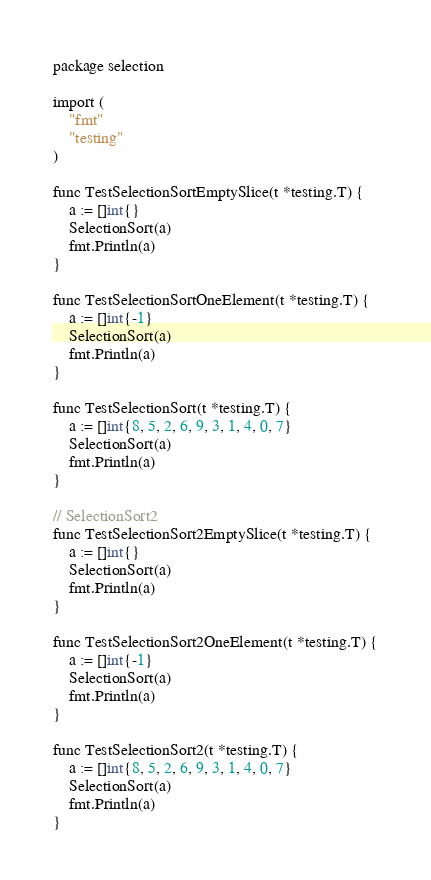<code> <loc_0><loc_0><loc_500><loc_500><_Go_>package selection

import (
	"fmt"
	"testing"
)

func TestSelectionSortEmptySlice(t *testing.T) {
	a := []int{}
	SelectionSort(a)
	fmt.Println(a)
}

func TestSelectionSortOneElement(t *testing.T) {
	a := []int{-1}
	SelectionSort(a)
	fmt.Println(a)
}

func TestSelectionSort(t *testing.T) {
	a := []int{8, 5, 2, 6, 9, 3, 1, 4, 0, 7}
	SelectionSort(a)
	fmt.Println(a)
}

// SelectionSort2
func TestSelectionSort2EmptySlice(t *testing.T) {
	a := []int{}
	SelectionSort(a)
	fmt.Println(a)
}

func TestSelectionSort2OneElement(t *testing.T) {
	a := []int{-1}
	SelectionSort(a)
	fmt.Println(a)
}

func TestSelectionSort2(t *testing.T) {
	a := []int{8, 5, 2, 6, 9, 3, 1, 4, 0, 7}
	SelectionSort(a)
	fmt.Println(a)
}
</code> 